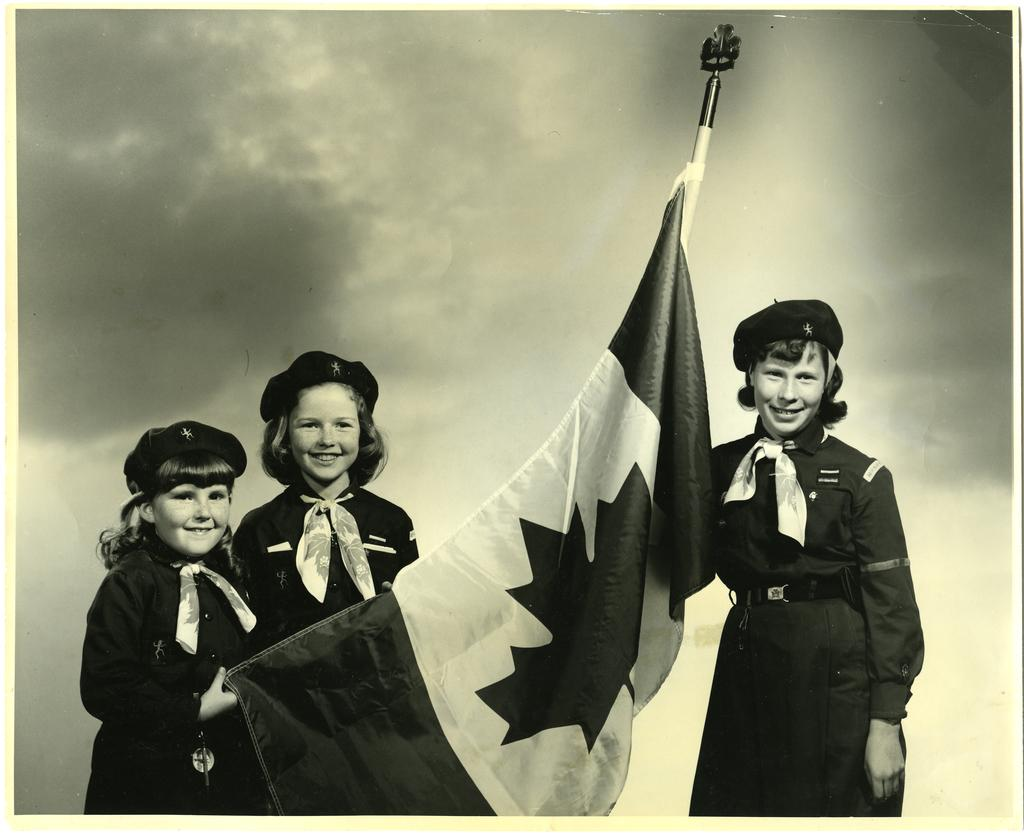What is the main subject of the picture? The main subject of the picture is children. What are the children holding in the picture? The children are holding a flag. What effect does the seashore have on the children's behavior in the image? There is no mention of a seashore in the image, so we cannot determine its effect on the children's behavior. 